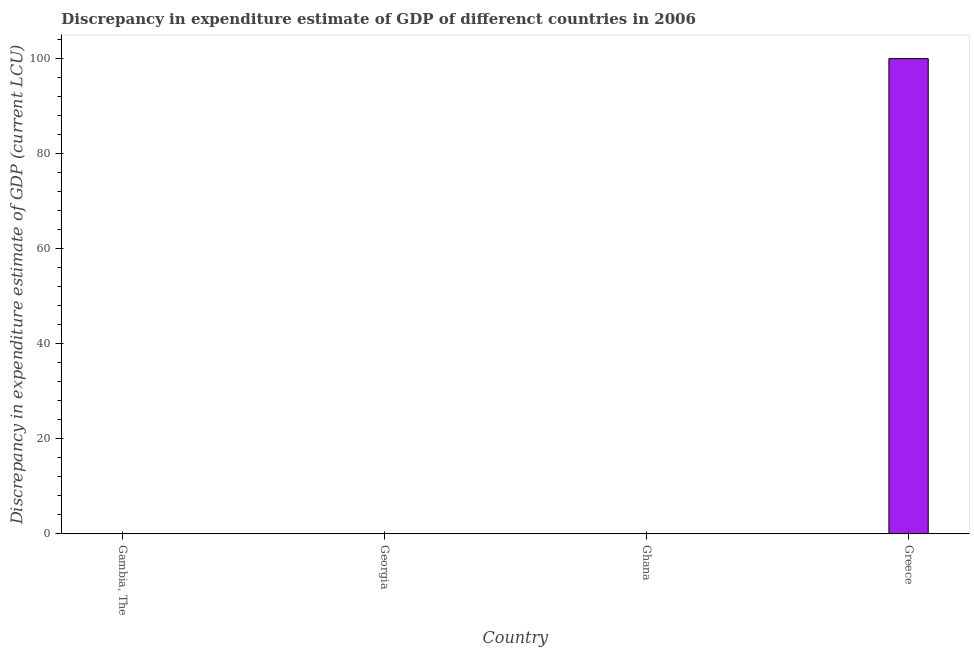Does the graph contain any zero values?
Give a very brief answer. Yes. Does the graph contain grids?
Give a very brief answer. No. What is the title of the graph?
Make the answer very short. Discrepancy in expenditure estimate of GDP of differenct countries in 2006. What is the label or title of the Y-axis?
Give a very brief answer. Discrepancy in expenditure estimate of GDP (current LCU). Across all countries, what is the maximum discrepancy in expenditure estimate of gdp?
Offer a very short reply. 100. Across all countries, what is the minimum discrepancy in expenditure estimate of gdp?
Keep it short and to the point. 0. What is the average discrepancy in expenditure estimate of gdp per country?
Make the answer very short. 25. In how many countries, is the discrepancy in expenditure estimate of gdp greater than 12 LCU?
Give a very brief answer. 1. What is the difference between the highest and the lowest discrepancy in expenditure estimate of gdp?
Provide a succinct answer. 100. Are all the bars in the graph horizontal?
Offer a very short reply. No. How many countries are there in the graph?
Provide a succinct answer. 4. Are the values on the major ticks of Y-axis written in scientific E-notation?
Your answer should be compact. No. What is the Discrepancy in expenditure estimate of GDP (current LCU) of Ghana?
Offer a terse response. 0. What is the Discrepancy in expenditure estimate of GDP (current LCU) of Greece?
Offer a terse response. 100. 